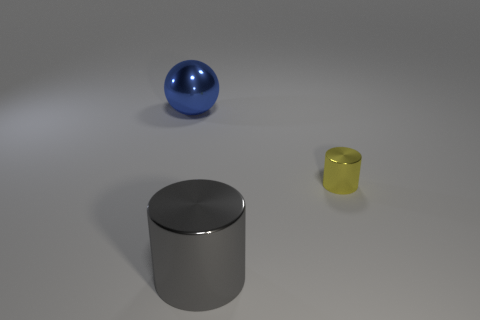Add 1 big shiny objects. How many objects exist? 4 Subtract all yellow cylinders. How many cylinders are left? 1 Subtract all cylinders. How many objects are left? 1 Subtract all purple spheres. How many yellow cylinders are left? 1 Subtract 1 balls. How many balls are left? 0 Subtract all green cylinders. Subtract all green spheres. How many cylinders are left? 2 Subtract all yellow objects. Subtract all gray cylinders. How many objects are left? 1 Add 3 metallic cylinders. How many metallic cylinders are left? 5 Add 2 brown metallic spheres. How many brown metallic spheres exist? 2 Subtract 0 green cubes. How many objects are left? 3 